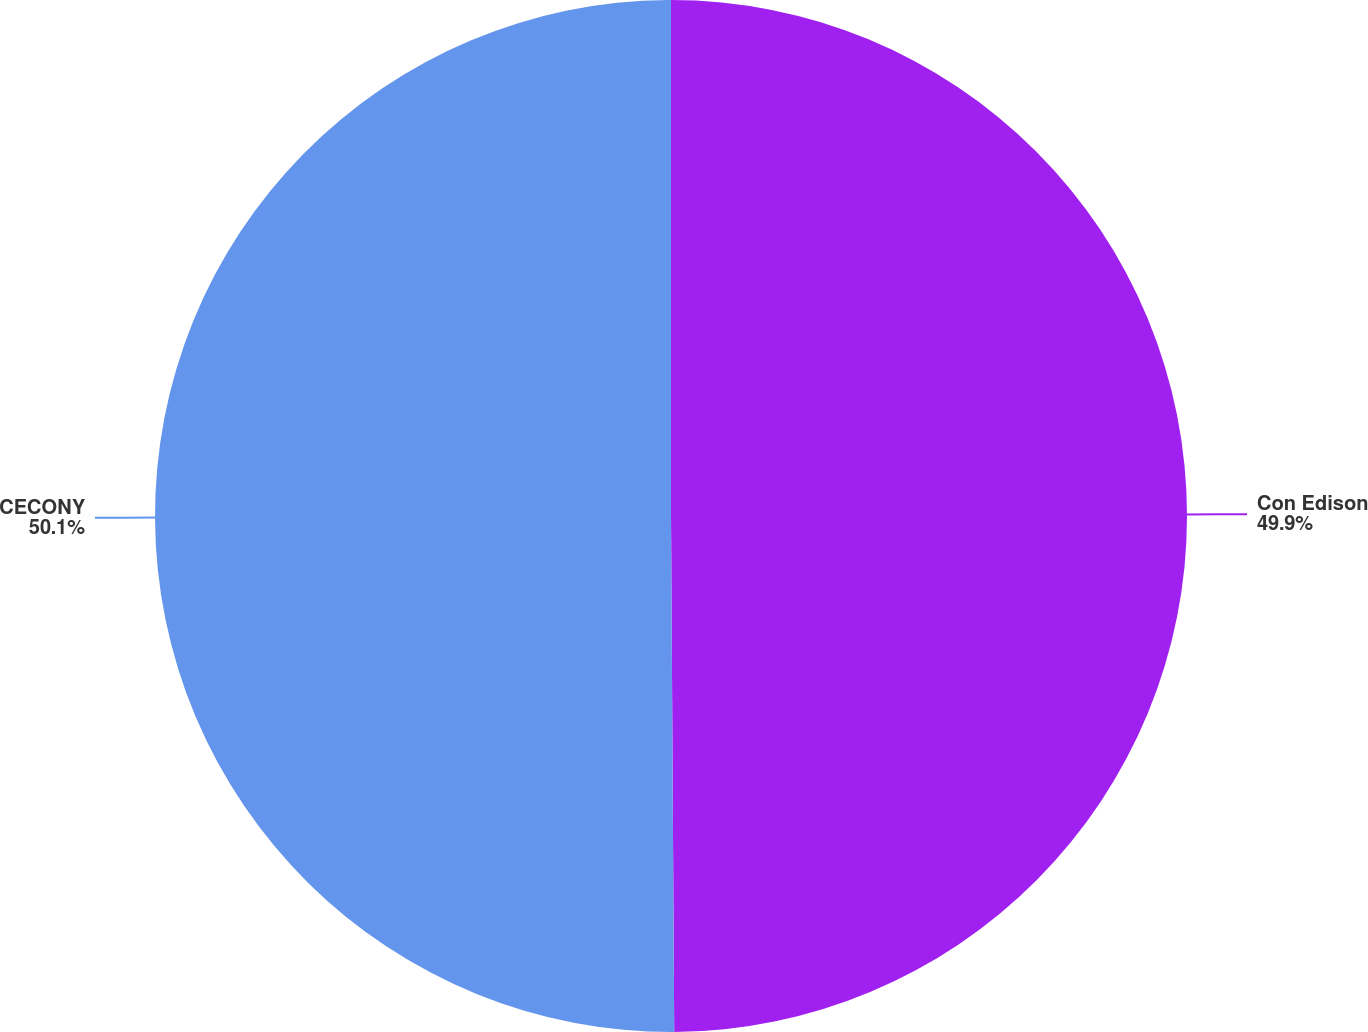<chart> <loc_0><loc_0><loc_500><loc_500><pie_chart><fcel>Con Edison<fcel>CECONY<nl><fcel>49.9%<fcel>50.1%<nl></chart> 